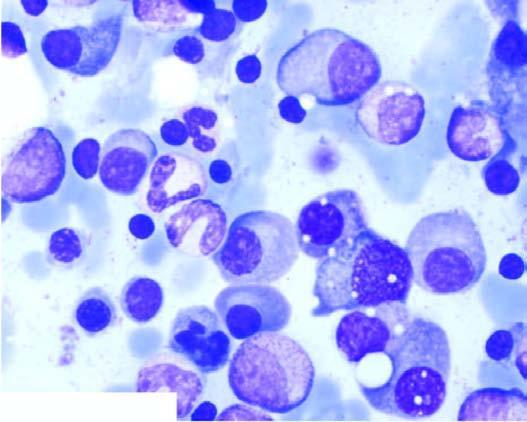what show numerous plasma cells, many with abnormal features?
Answer the question using a single word or phrase. Bone marrow aspirate 